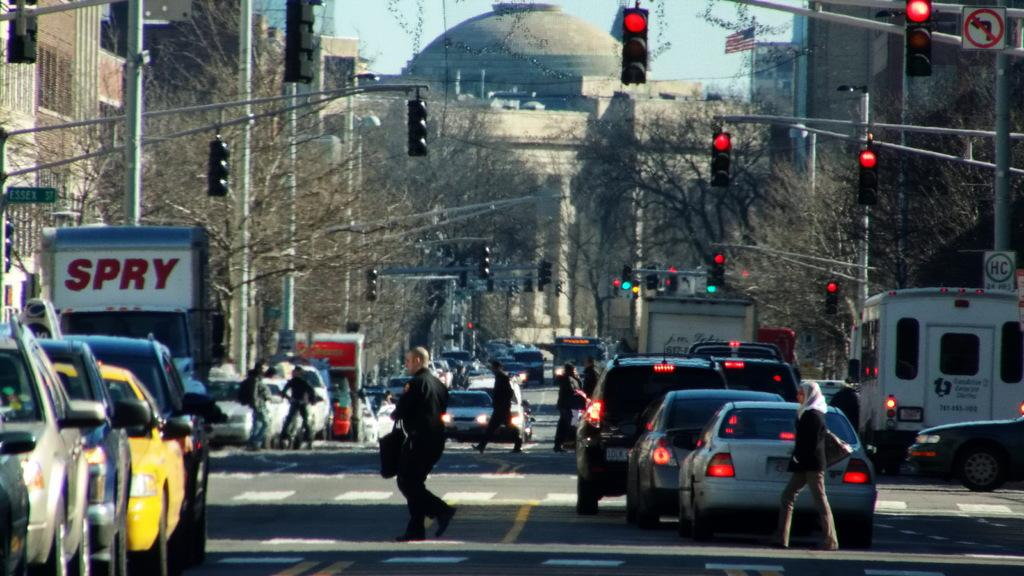<image>
Give a short and clear explanation of the subsequent image. a busy street with a truck that says spry 